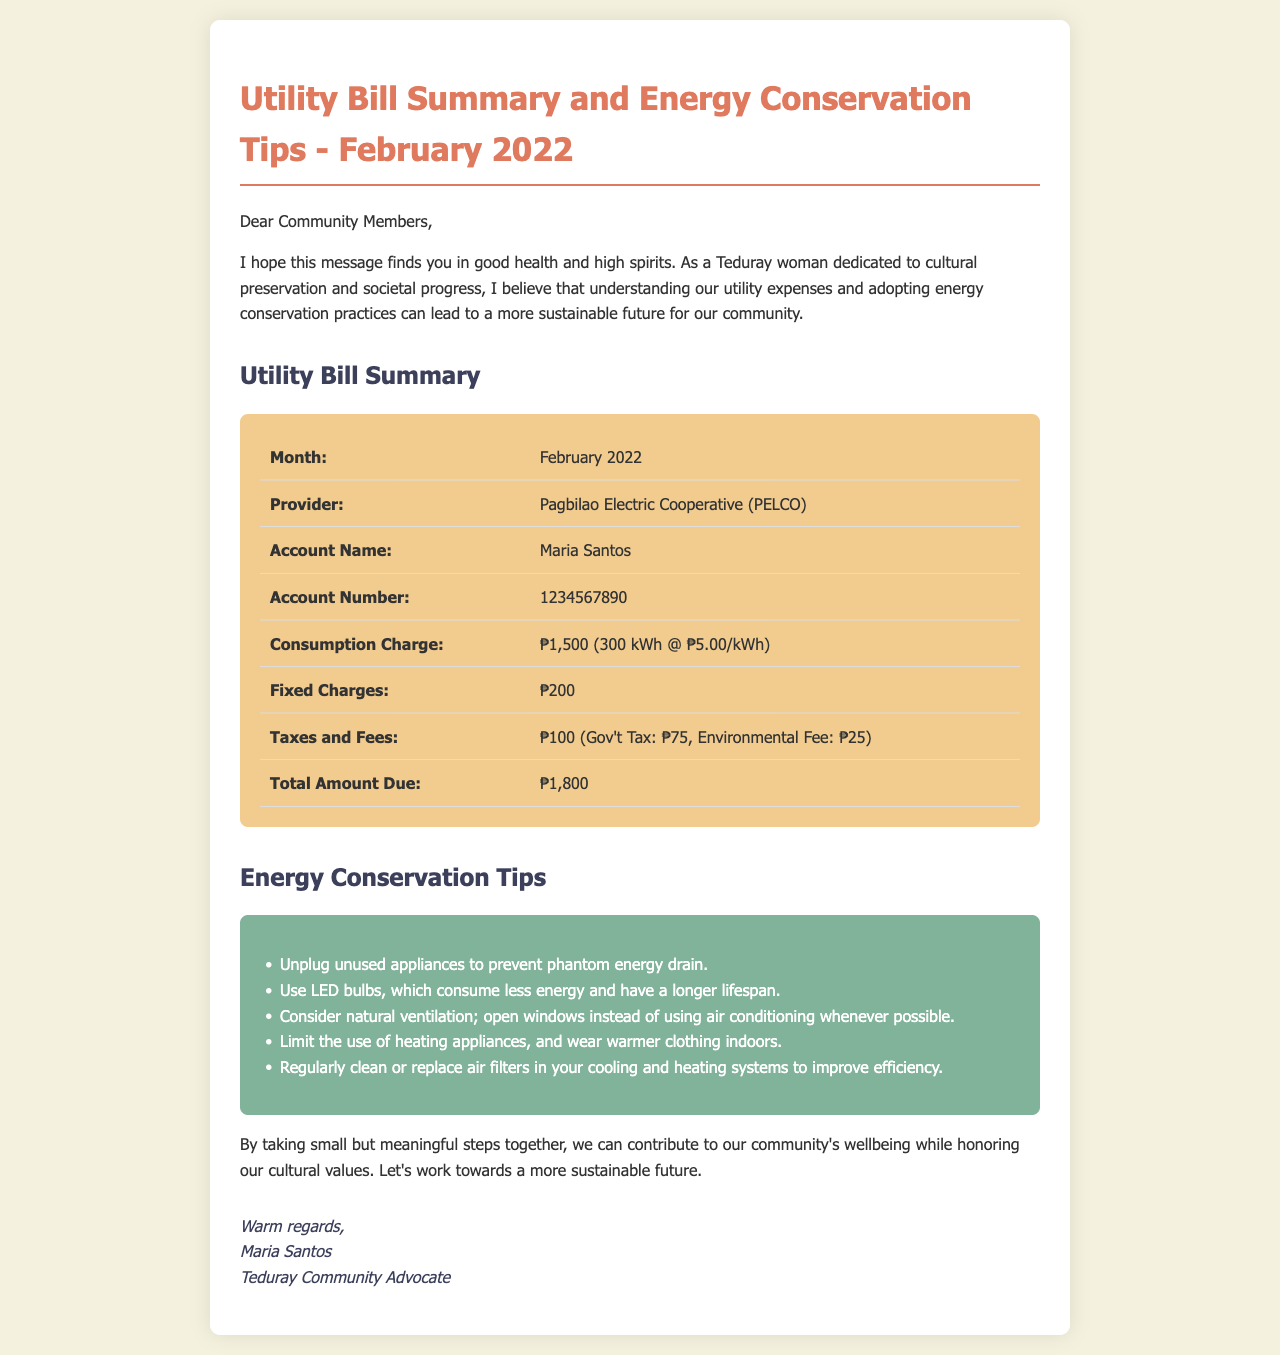What is the month of the utility bill? The document is specifically about the utility bill for February 2022.
Answer: February 2022 Who is the utility provider? The utility provider mentioned in the document is Pagbilao Electric Cooperative.
Answer: Pagbilao Electric Cooperative (PELCO) What is the total amount due? The total amount due is clearly indicated as ₱1,800 in the summary section.
Answer: ₱1,800 How much is the consumption charge for February? The consumption charge is described as ₱1,500 for 300 kWh at a rate of ₱5.00 per kWh.
Answer: ₱1,500 What tips are offered for energy conservation? The document lists several tips for energy conservation that can be referenced in the tips section.
Answer: Unplug unused appliances to prevent phantom energy drain How many kWh were consumed in February? The document mentions consumption of 300 kWh for the stated period.
Answer: 300 kWh What are the fixed charges in the bill? The fixed charges are specified clearly as ₱200 in the utility bill summary.
Answer: ₱200 What are the components of taxes and fees? The document breaks down taxes and fees into Government Tax and Environmental Fee totaling ₱100.
Answer: ₱100 (Gov't Tax: ₱75, Environmental Fee: ₱25) What is the purpose of this document? The document aims to summarize the utility bill and provide tips for energy conservation.
Answer: Utility Bill Summary and Energy Conservation Tips 